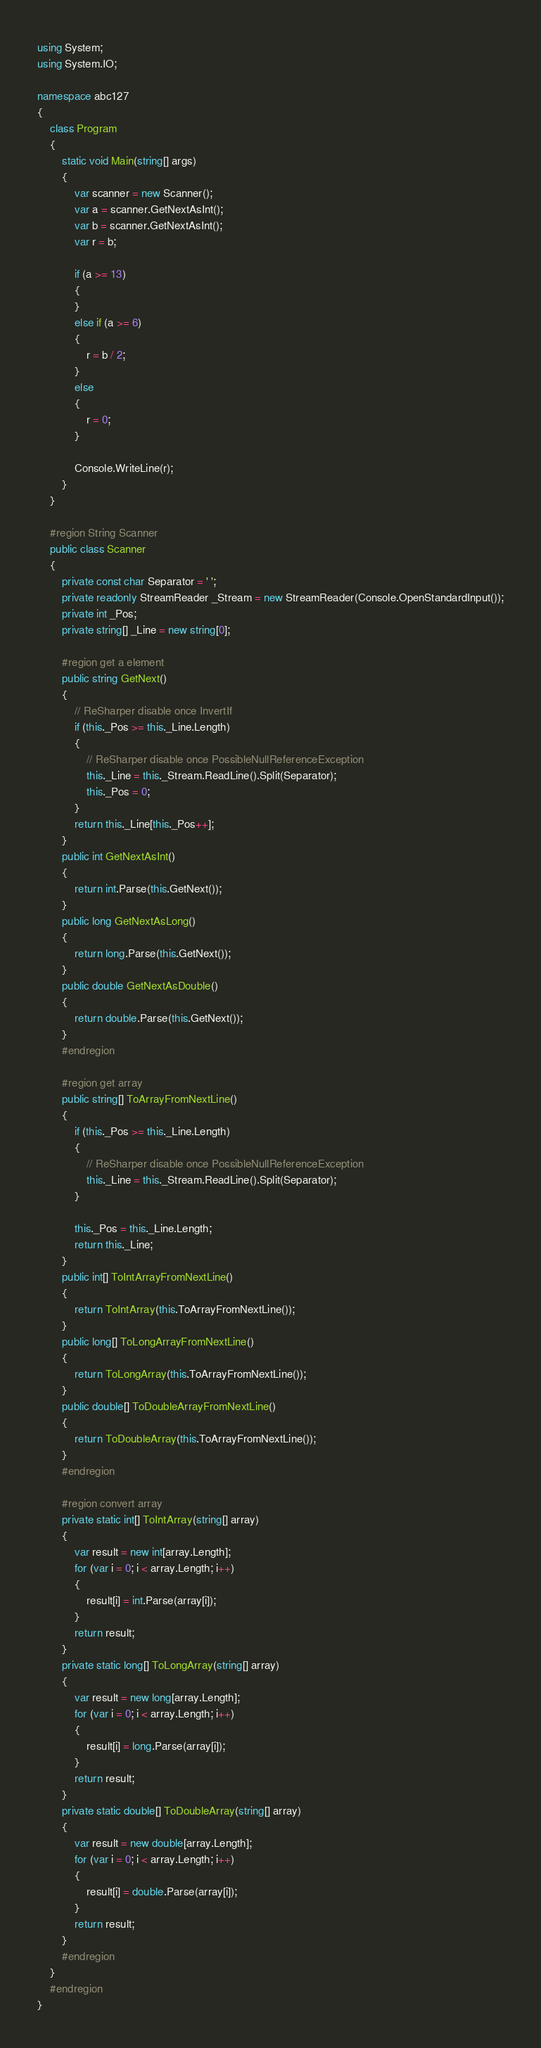Convert code to text. <code><loc_0><loc_0><loc_500><loc_500><_C#_>using System;
using System.IO;

namespace abc127
{
    class Program
    {
        static void Main(string[] args)
        {
            var scanner = new Scanner();
            var a = scanner.GetNextAsInt();
            var b = scanner.GetNextAsInt();
            var r = b;

            if (a >= 13)
            {
            }
            else if (a >= 6)
            {
                r = b / 2;
            }
            else
            {
                r = 0;
            }

            Console.WriteLine(r);
        }
    }

    #region String Scanner
    public class Scanner
    {
        private const char Separator = ' ';
        private readonly StreamReader _Stream = new StreamReader(Console.OpenStandardInput());
        private int _Pos;
        private string[] _Line = new string[0];

        #region get a element
        public string GetNext()
        {
            // ReSharper disable once InvertIf
            if (this._Pos >= this._Line.Length)
            {
                // ReSharper disable once PossibleNullReferenceException
                this._Line = this._Stream.ReadLine().Split(Separator);
                this._Pos = 0;
            }
            return this._Line[this._Pos++];
        }
        public int GetNextAsInt()
        {
            return int.Parse(this.GetNext());
        }
        public long GetNextAsLong()
        {
            return long.Parse(this.GetNext());
        }
        public double GetNextAsDouble()
        {
            return double.Parse(this.GetNext());
        }
        #endregion

        #region get array
        public string[] ToArrayFromNextLine()
        {
            if (this._Pos >= this._Line.Length)
            {
                // ReSharper disable once PossibleNullReferenceException
                this._Line = this._Stream.ReadLine().Split(Separator);
            }

            this._Pos = this._Line.Length;
            return this._Line;
        }
        public int[] ToIntArrayFromNextLine()
        {
            return ToIntArray(this.ToArrayFromNextLine());
        }
        public long[] ToLongArrayFromNextLine()
        {
            return ToLongArray(this.ToArrayFromNextLine());
        }
        public double[] ToDoubleArrayFromNextLine()
        {
            return ToDoubleArray(this.ToArrayFromNextLine());
        }
        #endregion

        #region convert array
        private static int[] ToIntArray(string[] array)
        {
            var result = new int[array.Length];
            for (var i = 0; i < array.Length; i++)
            {
                result[i] = int.Parse(array[i]);
            }
            return result;
        }
        private static long[] ToLongArray(string[] array)
        {
            var result = new long[array.Length];
            for (var i = 0; i < array.Length; i++)
            {
                result[i] = long.Parse(array[i]);
            }
            return result;
        }
        private static double[] ToDoubleArray(string[] array)
        {
            var result = new double[array.Length];
            for (var i = 0; i < array.Length; i++)
            {
                result[i] = double.Parse(array[i]);
            }
            return result;
        }
        #endregion
    }
    #endregion
}
</code> 